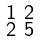Convert formula to latex. <formula><loc_0><loc_0><loc_500><loc_500>\begin{smallmatrix} 1 & 2 \\ 2 & 5 \end{smallmatrix}</formula> 